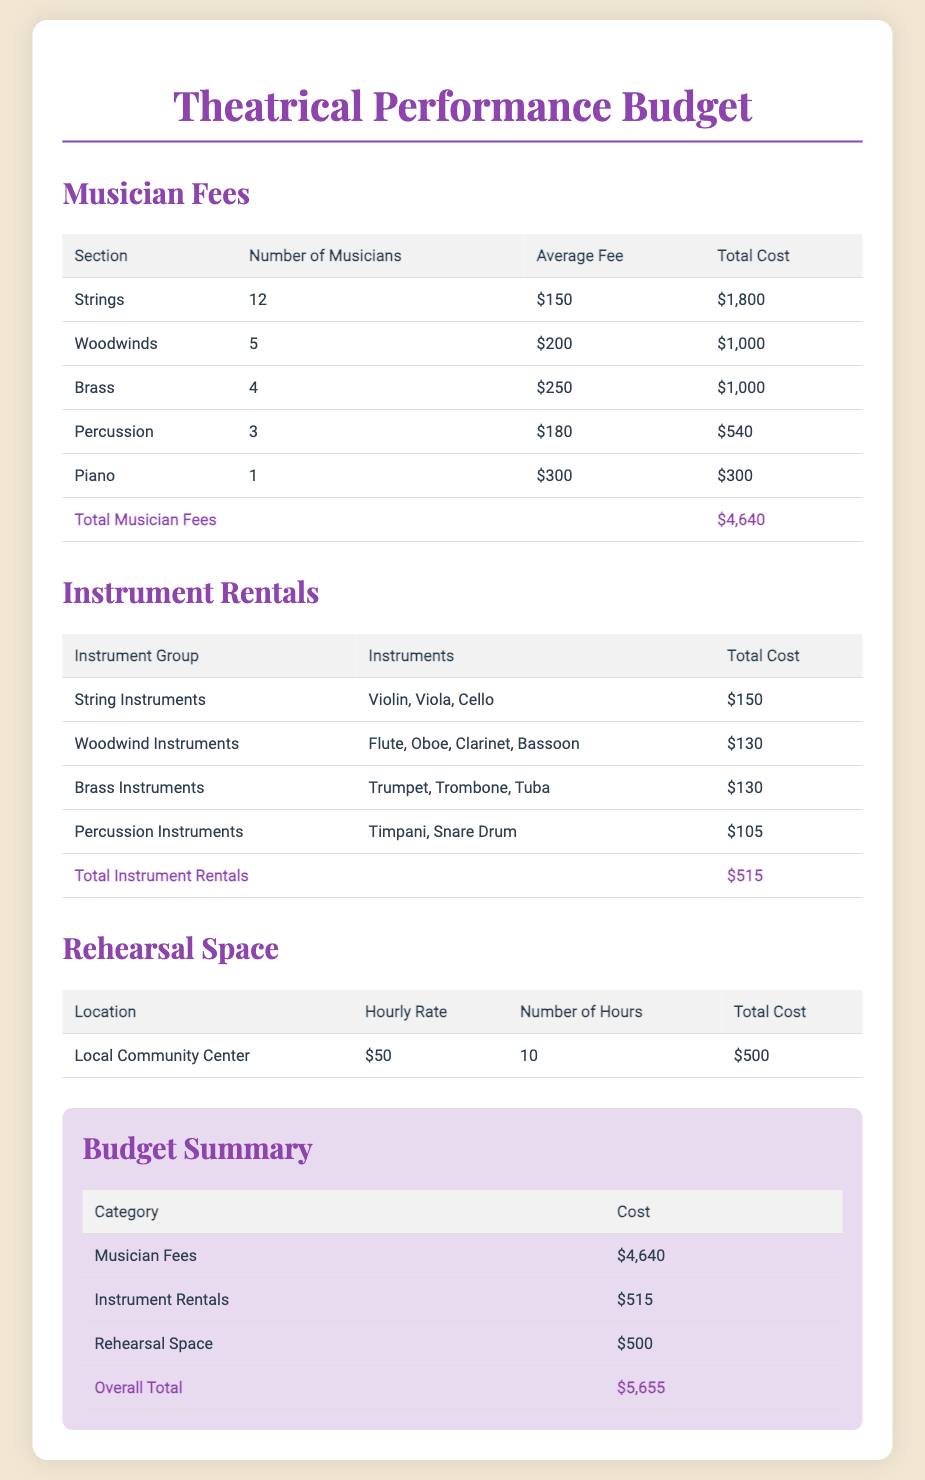what is the total cost for musician fees? The total cost for musician fees is found in the summary table under the category "Musician Fees," which is $4,640.
Answer: $4,640 how many woodwind musicians are hired? The number of woodwind musicians is specified in the musician fees table, which states there are 5 woodwind musicians.
Answer: 5 what is the total cost for instrument rentals? The total cost for instrument rentals can be found in the summary table under "Instrument Rentals," which is $515.
Answer: $515 how much does it cost to rent percussion instruments? The table for instrument rentals specifies the cost for percussion instruments as $105.
Answer: $105 what is the hourly rate for the rehearsal space? The hourly rate for the rehearsal space is listed as $50 in the rehearsal space table.
Answer: $50 which section of musicians has the highest average fee? The musician fees table shows that the Brass section has the highest average fee of $250.
Answer: Brass what is the total cost for rehearsal space? The total cost for rehearsal space is provided in the rehearsal space table, which states it is $500.
Answer: $500 how many total categories are summarized in the budget summary? The budget summary contains three categories: Musician Fees, Instrument Rentals, and Rehearsal Space.
Answer: 3 what is the overall total cost for the theatrical performance? The overall total cost is located in the budget summary, where it states the total is $5,655.
Answer: $5,655 